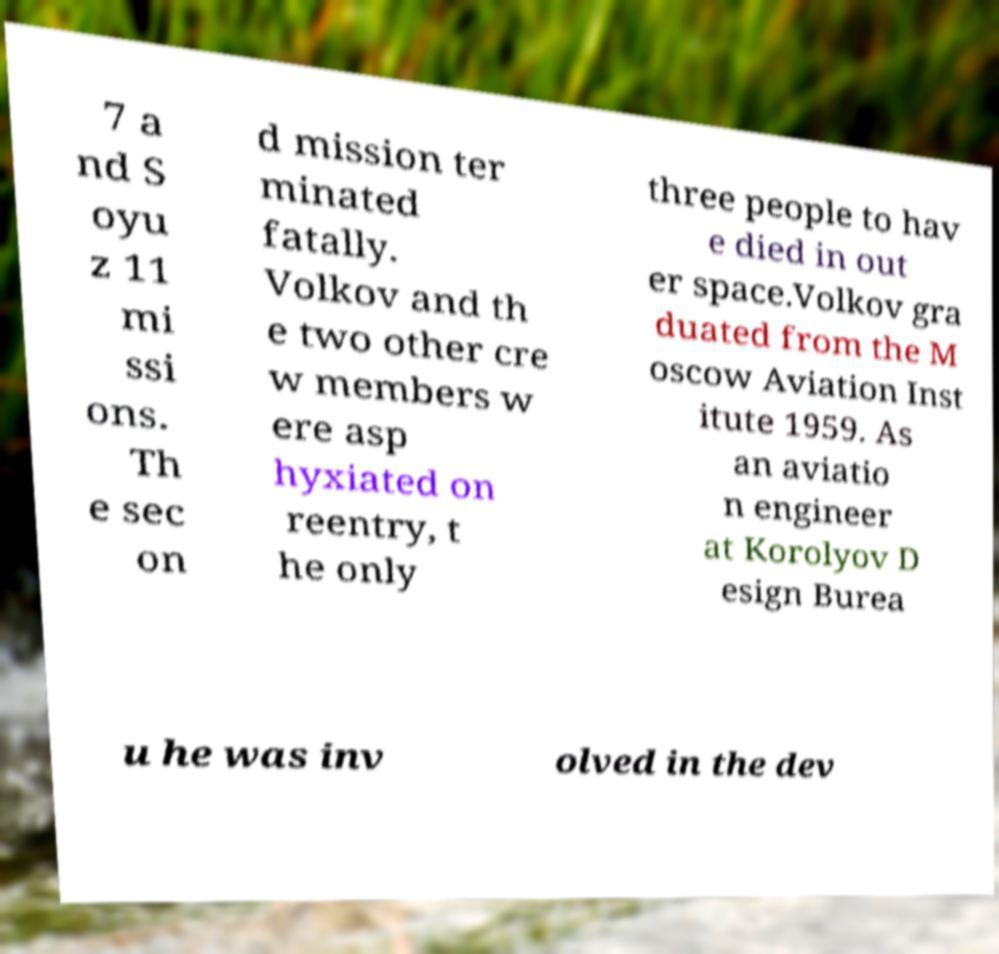Please read and relay the text visible in this image. What does it say? 7 a nd S oyu z 11 mi ssi ons. Th e sec on d mission ter minated fatally. Volkov and th e two other cre w members w ere asp hyxiated on reentry, t he only three people to hav e died in out er space.Volkov gra duated from the M oscow Aviation Inst itute 1959. As an aviatio n engineer at Korolyov D esign Burea u he was inv olved in the dev 